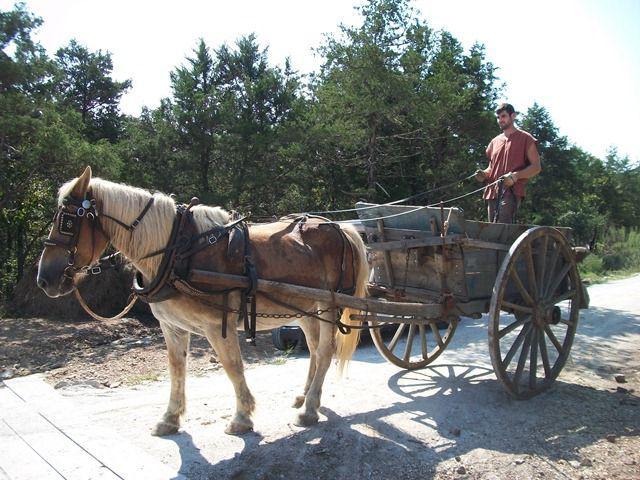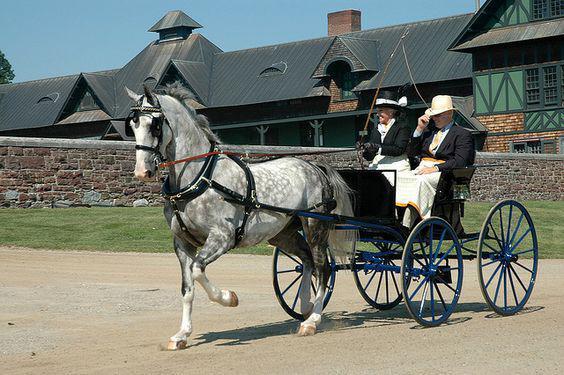The first image is the image on the left, the second image is the image on the right. For the images displayed, is the sentence "there is exactly one person in the image on the right." factually correct? Answer yes or no. No. 